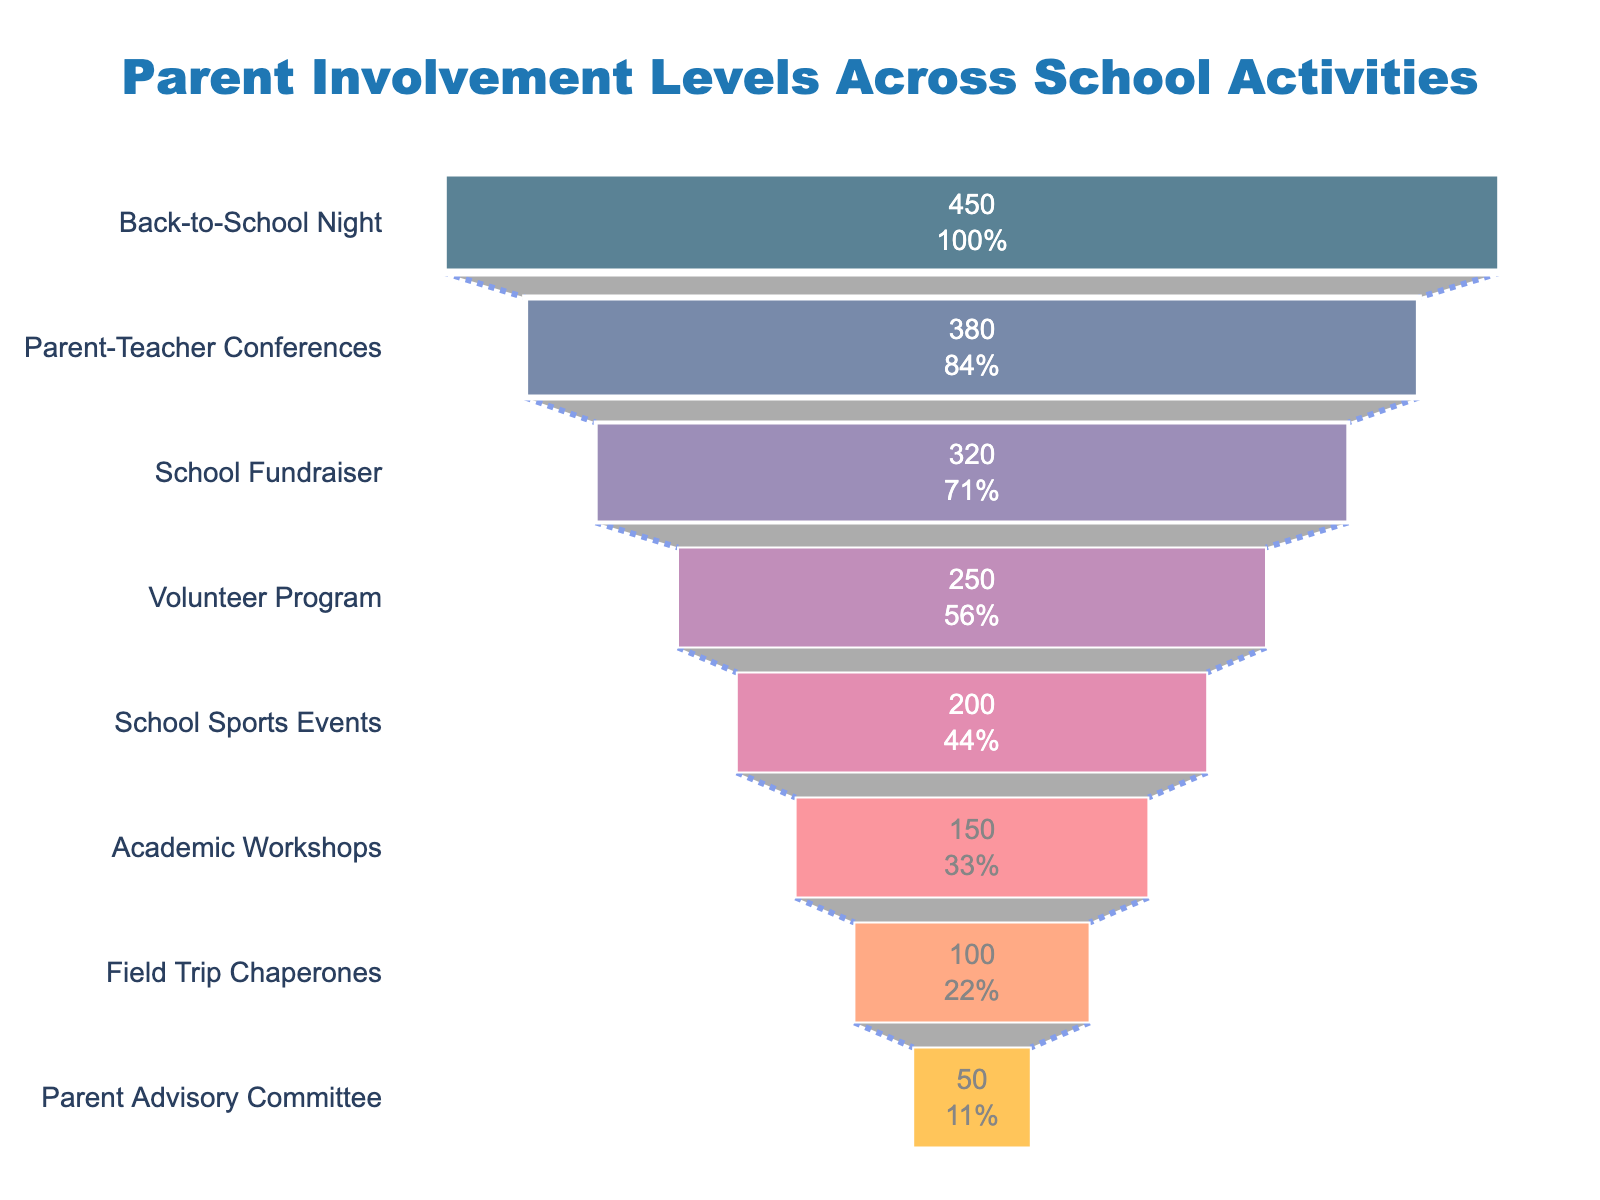What is the title of the chart? The title of the chart is displayed at the top of the figure. It reads "Parent Involvement Levels Across School Activities".
Answer: Parent Involvement Levels Across School Activities How many activities are listed on the funnel chart? The funnel chart lists the number of distinct activities by looking at the y-axis labels. It shows eight activities.
Answer: Eight Which activity has the highest parent involvement? On the funnel chart, the activity at the top is "Back-to-School Night," indicating the highest parent involvement.
Answer: Back-to-School Night What percentage of initial parent involvement participates in the School Fundraiser? "School Fundraiser" is the third activity in the funnel. The chart shows the percentage value next to the number, which is 71% of initial involvement.
Answer: 71% How many more parents are involved in Parent-Teacher Conferences compared to the Volunteer Program? The number of parents in Parent-Teacher Conferences is 380, and in the Volunteer Program, it is 250. The difference is calculated as 380 - 250 = 130.
Answer: 130 Which activity has the lowest parent involvement? The last activity at the bottom of the funnel, indicating the lowest parent involvement, is the "Parent Advisory Committee."
Answer: Parent Advisory Committee What's the total number of parents involved in the top three activities combined? Add the values of the top three activities: Back-to-School Night (450), Parent-Teacher Conferences (380), and School Fundraiser (320). The total is 450 + 380 + 320 = 1150.
Answer: 1150 What is the difference between the number of parents involved in School Sports Events and Academic Workshops? The chart shows 200 parents are involved in School Sports Events and 150 in Academic Workshops. The difference is 200 - 150 = 50.
Answer: 50 How does the involvement in Field Trip Chaperones compare to the Parent Advisory Committee? The number of parents involved in Field Trip Chaperones is 100, and for the Parent Advisory Committee, it is 50. Field Trip Chaperones have twice as much involvement, which is 100/50 = 2 times.
Answer: 2 times What trends do you notice in parent involvement as you move down the funnel chart? Moving down the funnel chart, there is a clear decreasing trend in parent involvement, starting from the most involved activity and dropping to the least involved one.
Answer: Decreasing trend 